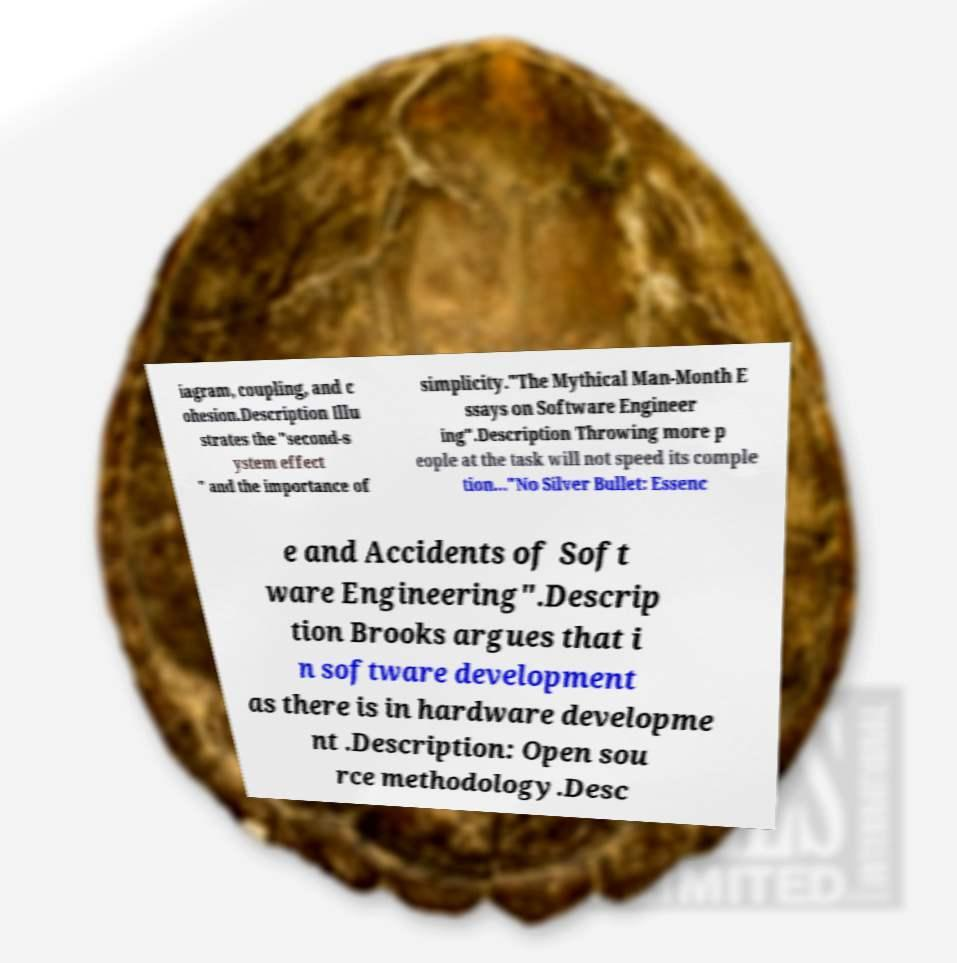Can you accurately transcribe the text from the provided image for me? iagram, coupling, and c ohesion.Description Illu strates the "second-s ystem effect " and the importance of simplicity."The Mythical Man-Month E ssays on Software Engineer ing".Description Throwing more p eople at the task will not speed its comple tion..."No Silver Bullet: Essenc e and Accidents of Soft ware Engineering".Descrip tion Brooks argues that i n software development as there is in hardware developme nt .Description: Open sou rce methodology.Desc 